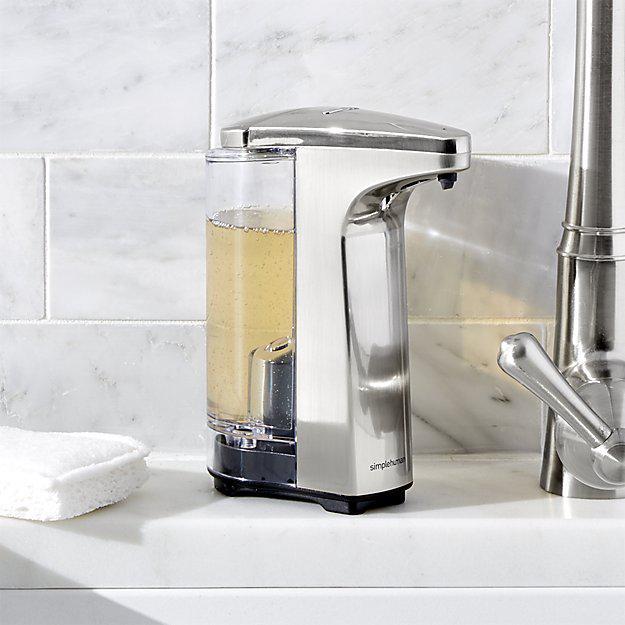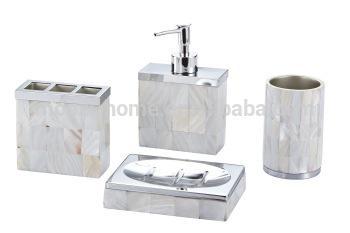The first image is the image on the left, the second image is the image on the right. For the images displayed, is the sentence "At least one of the images shows a dual wall dispenser." factually correct? Answer yes or no. No. The first image is the image on the left, the second image is the image on the right. Evaluate the accuracy of this statement regarding the images: "At least one image is of items that are not wall mounted.". Is it true? Answer yes or no. Yes. 